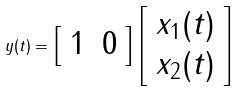Convert formula to latex. <formula><loc_0><loc_0><loc_500><loc_500>y ( t ) = \left [ { \begin{array} { l l } { 1 } & { 0 } \end{array} } \right ] \left [ { \begin{array} { l } { x _ { 1 } ( t ) } \\ { x _ { 2 } ( t ) } \end{array} } \right ]</formula> 